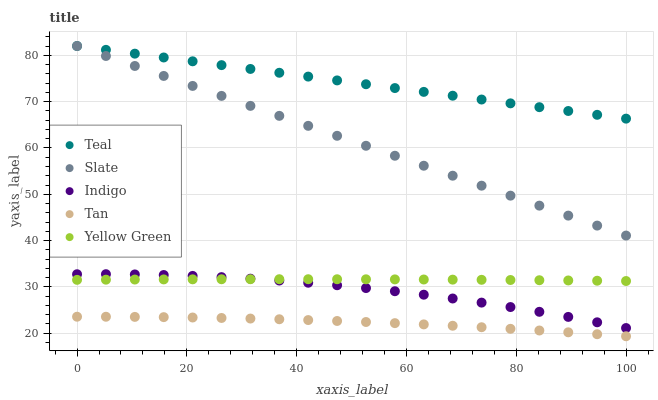Does Tan have the minimum area under the curve?
Answer yes or no. Yes. Does Teal have the maximum area under the curve?
Answer yes or no. Yes. Does Indigo have the minimum area under the curve?
Answer yes or no. No. Does Indigo have the maximum area under the curve?
Answer yes or no. No. Is Teal the smoothest?
Answer yes or no. Yes. Is Indigo the roughest?
Answer yes or no. Yes. Is Tan the smoothest?
Answer yes or no. No. Is Tan the roughest?
Answer yes or no. No. Does Tan have the lowest value?
Answer yes or no. Yes. Does Indigo have the lowest value?
Answer yes or no. No. Does Teal have the highest value?
Answer yes or no. Yes. Does Indigo have the highest value?
Answer yes or no. No. Is Yellow Green less than Teal?
Answer yes or no. Yes. Is Teal greater than Yellow Green?
Answer yes or no. Yes. Does Teal intersect Slate?
Answer yes or no. Yes. Is Teal less than Slate?
Answer yes or no. No. Is Teal greater than Slate?
Answer yes or no. No. Does Yellow Green intersect Teal?
Answer yes or no. No. 